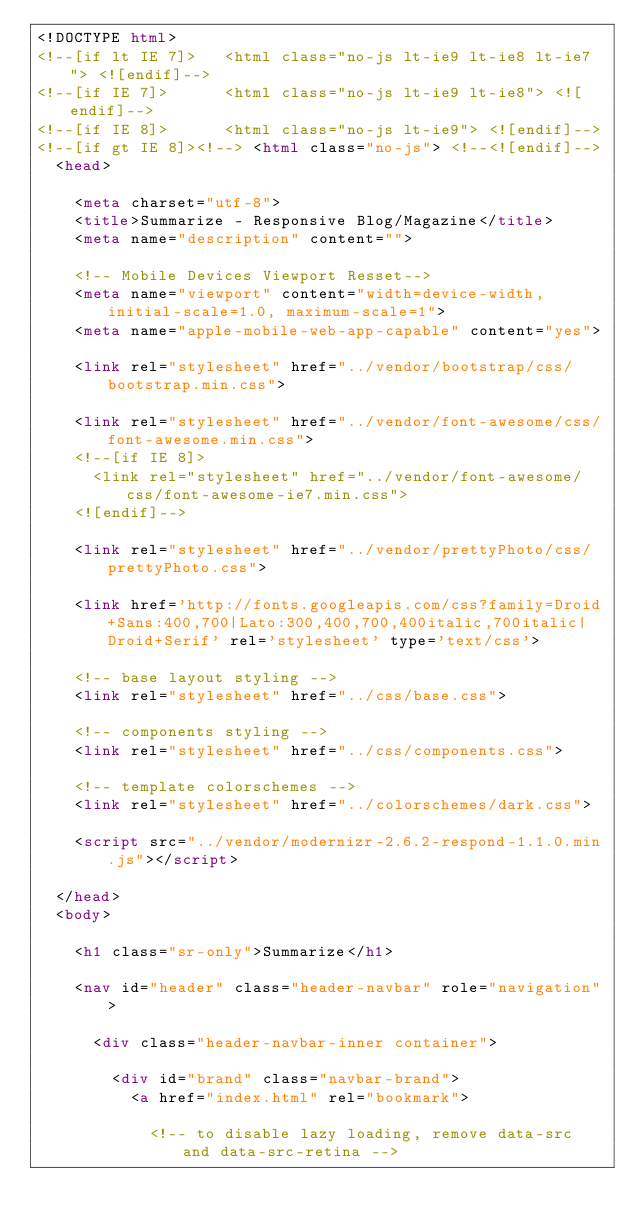<code> <loc_0><loc_0><loc_500><loc_500><_HTML_><!DOCTYPE html>
<!--[if lt IE 7]>   <html class="no-js lt-ie9 lt-ie8 lt-ie7"> <![endif]-->
<!--[if IE 7]>      <html class="no-js lt-ie9 lt-ie8"> <![endif]-->
<!--[if IE 8]>      <html class="no-js lt-ie9"> <![endif]-->
<!--[if gt IE 8]><!--> <html class="no-js"> <!--<![endif]-->
	<head>

		<meta charset="utf-8">
		<title>Summarize - Responsive Blog/Magazine</title>
		<meta name="description" content="">

		<!-- Mobile Devices Viewport Resset-->
		<meta name="viewport" content="width=device-width, initial-scale=1.0, maximum-scale=1">
		<meta name="apple-mobile-web-app-capable" content="yes">

		<link rel="stylesheet" href="../vendor/bootstrap/css/bootstrap.min.css">

		<link rel="stylesheet" href="../vendor/font-awesome/css/font-awesome.min.css">
		<!--[if IE 8]>
			<link rel="stylesheet" href="../vendor/font-awesome/css/font-awesome-ie7.min.css">
		<![endif]-->

		<link rel="stylesheet" href="../vendor/prettyPhoto/css/prettyPhoto.css">

		<link href='http://fonts.googleapis.com/css?family=Droid+Sans:400,700|Lato:300,400,700,400italic,700italic|Droid+Serif' rel='stylesheet' type='text/css'>

		<!-- base layout styling -->
		<link rel="stylesheet" href="../css/base.css">

		<!-- components styling -->
		<link rel="stylesheet" href="../css/components.css">
		
		<!-- template colorschemes -->
		<link rel="stylesheet" href="../colorschemes/dark.css">

		<script src="../vendor/modernizr-2.6.2-respond-1.1.0.min.js"></script>

	</head>
	<body>

		<h1 class="sr-only">Summarize</h1>
			
		<nav id="header" class="header-navbar" role="navigation">

			<div class="header-navbar-inner container">
			
				<div id="brand" class="navbar-brand">
					<a href="index.html" rel="bookmark">

						<!-- to disable lazy loading, remove data-src and data-src-retina --></code> 